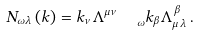Convert formula to latex. <formula><loc_0><loc_0><loc_500><loc_500>N _ { \omega \lambda } \left ( k \right ) = k _ { \nu } \Lambda _ { \quad \omega } ^ { \mu \nu } k _ { \beta } \Lambda _ { \mu \, \lambda } ^ { \, \beta } \, .</formula> 